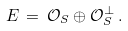Convert formula to latex. <formula><loc_0><loc_0><loc_500><loc_500>E \, = \, \mathcal { O } _ { S } \oplus \mathcal { O } _ { S } ^ { \perp } \, .</formula> 